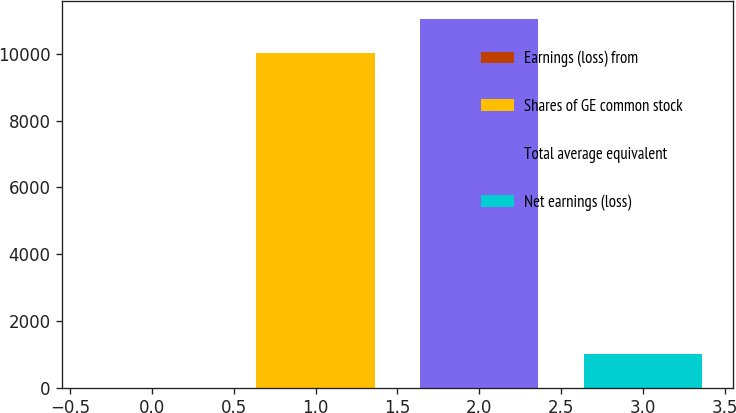Convert chart to OTSL. <chart><loc_0><loc_0><loc_500><loc_500><bar_chart><fcel>Earnings (loss) from<fcel>Shares of GE common stock<fcel>Total average equivalent<fcel>Net earnings (loss)<nl><fcel>0.57<fcel>10045<fcel>11049.4<fcel>1005.01<nl></chart> 